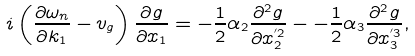<formula> <loc_0><loc_0><loc_500><loc_500>i \left ( \frac { \partial \omega _ { n } } { \partial k _ { 1 } } - v _ { g } \right ) \frac { \partial g } { \partial x _ { 1 } } = - \frac { 1 } { 2 } \alpha _ { 2 } \frac { \partial ^ { 2 } g } { \partial x ^ { ^ { \prime } 2 } _ { 2 } } - - \frac { 1 } { 2 } \alpha _ { 3 } \frac { \partial ^ { 2 } g } { \partial x ^ { ^ { \prime } 3 } _ { 3 } } ,</formula> 